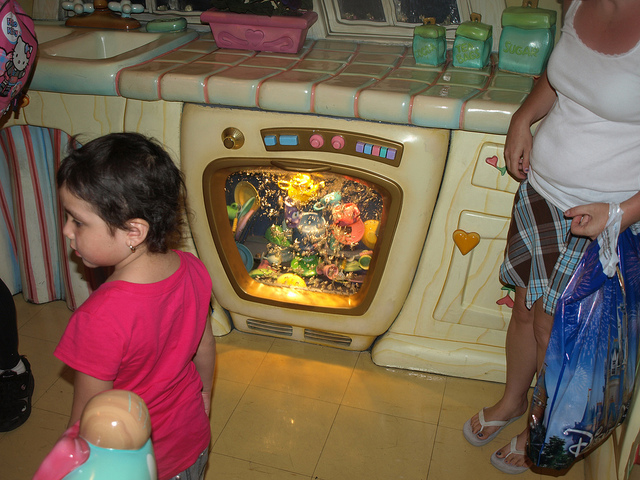How many children are in the photo? There is one child visible in the photo, standing to the left side, wearing a bright pink top. 